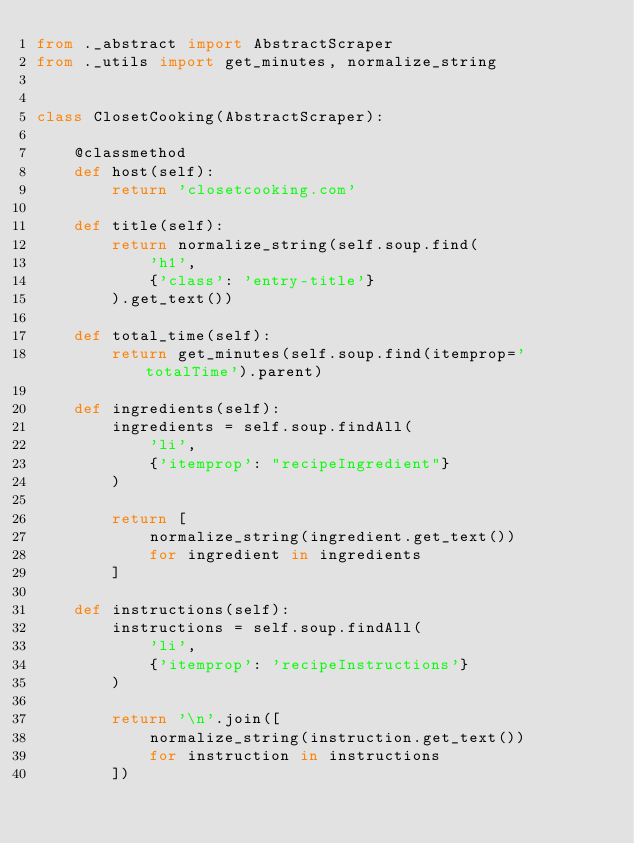Convert code to text. <code><loc_0><loc_0><loc_500><loc_500><_Python_>from ._abstract import AbstractScraper
from ._utils import get_minutes, normalize_string


class ClosetCooking(AbstractScraper):

    @classmethod
    def host(self):
        return 'closetcooking.com'

    def title(self):
        return normalize_string(self.soup.find(
            'h1',
            {'class': 'entry-title'}
        ).get_text())

    def total_time(self):
        return get_minutes(self.soup.find(itemprop='totalTime').parent)

    def ingredients(self):
        ingredients = self.soup.findAll(
            'li',
            {'itemprop': "recipeIngredient"}
        )

        return [
            normalize_string(ingredient.get_text())
            for ingredient in ingredients
        ]

    def instructions(self):
        instructions = self.soup.findAll(
            'li',
            {'itemprop': 'recipeInstructions'}
        )

        return '\n'.join([
            normalize_string(instruction.get_text())
            for instruction in instructions
        ])
</code> 